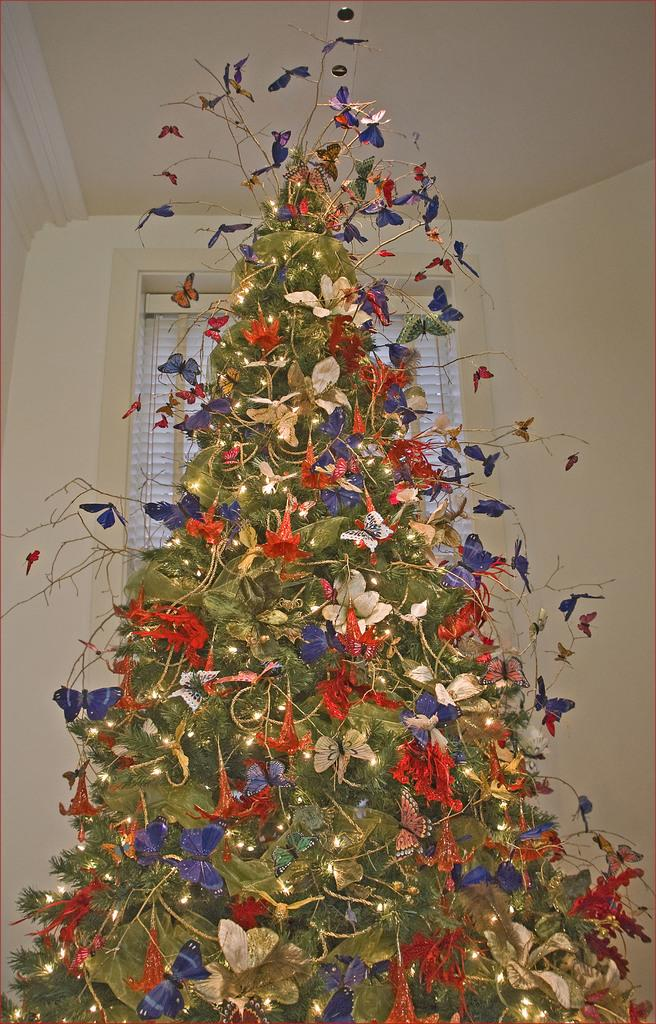What is the main subject of the image? There is a Christmas tree in the image. What else can be seen in the image besides the Christmas tree? There are decorative items in the image. What can be seen in the background of the image? There is a wall, a window, and a roof in the background of the image. What type of mask is being worn by the truck in the image? There is no truck or mask present in the image. 